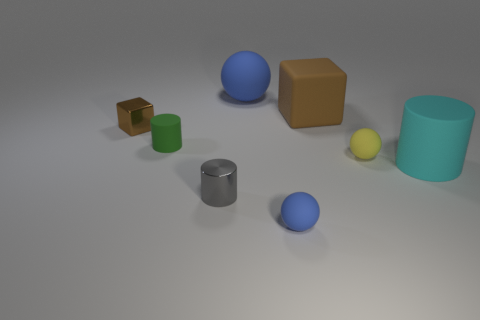If you had to guess, what could these objects be used for in a real-world setting? The objects appear as basic geometric shapes which could serve educational purposes, such as in a classroom setting for teaching geometry, volume, and spatial relations. They could also be props or models in a design or architectural context. 